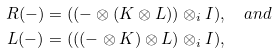Convert formula to latex. <formula><loc_0><loc_0><loc_500><loc_500>R ( - ) & = ( ( - \otimes ( K \otimes L ) ) \otimes _ { i } I ) , \quad a n d \\ L ( - ) & = ( ( ( - \otimes K ) \otimes L ) \otimes _ { i } I ) ,</formula> 